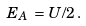<formula> <loc_0><loc_0><loc_500><loc_500>E _ { A } \, = \, U / 2 \, .</formula> 